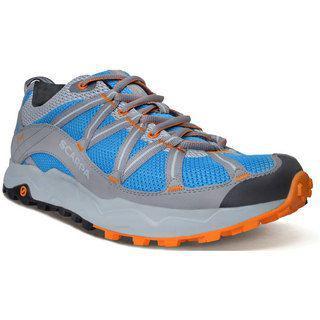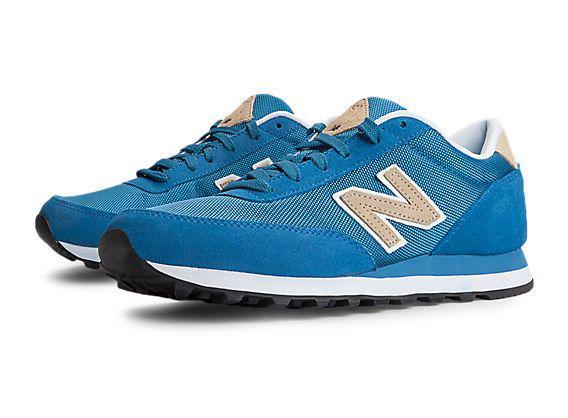The first image is the image on the left, the second image is the image on the right. Evaluate the accuracy of this statement regarding the images: "there is only one shoe on the right image on a white background". Is it true? Answer yes or no. No. 